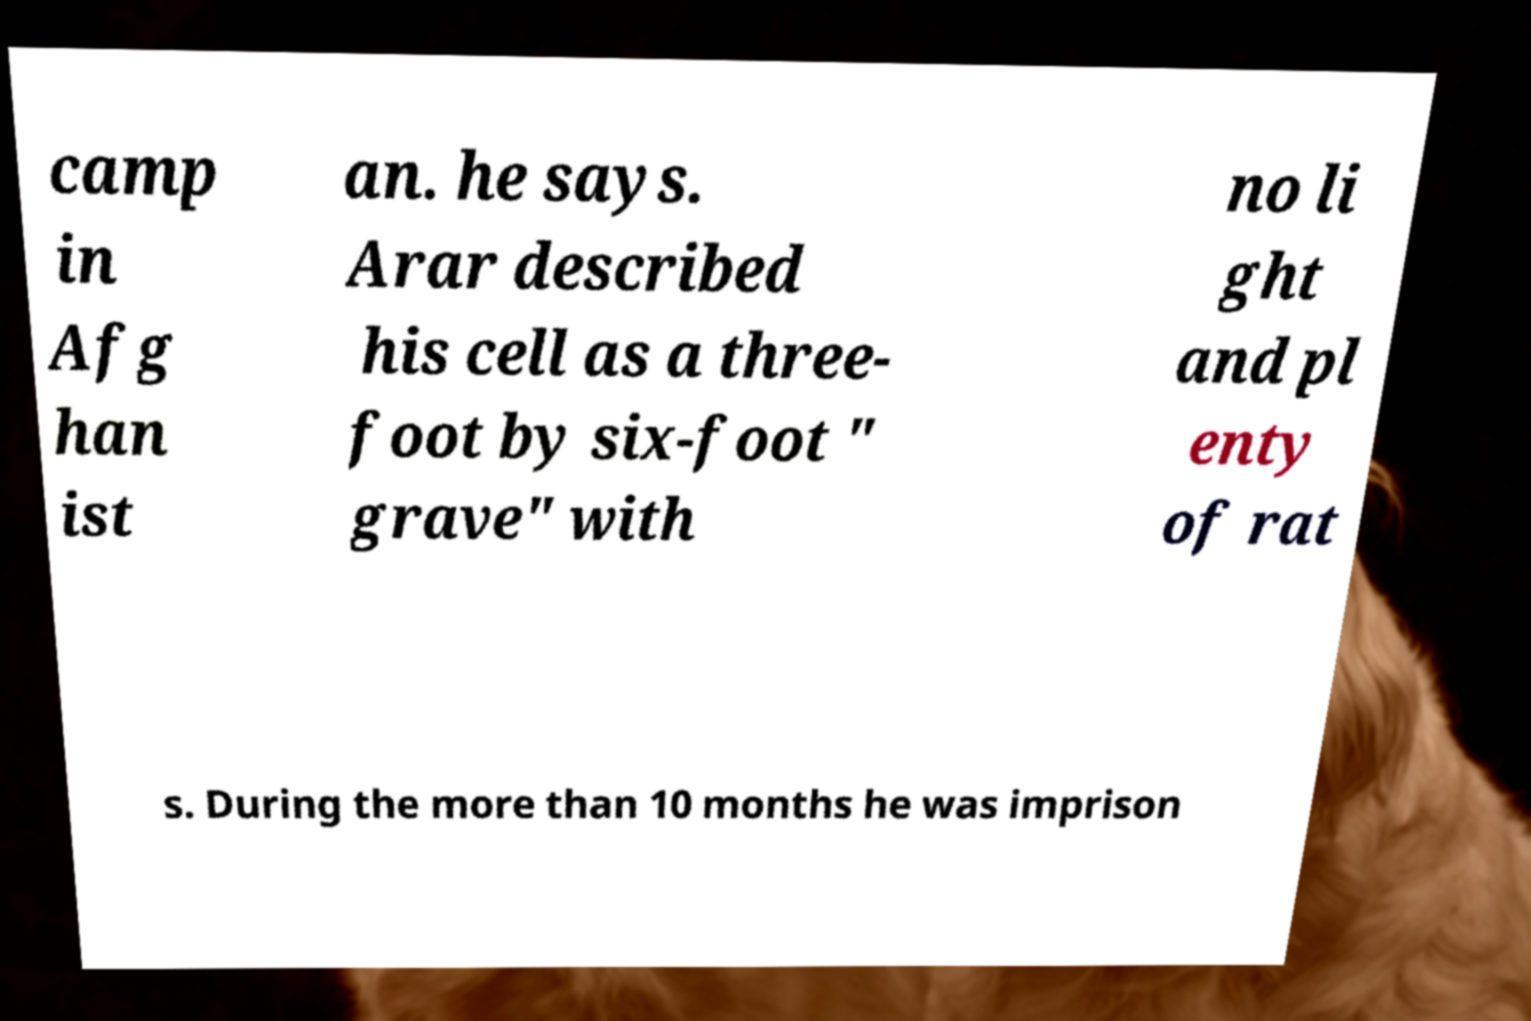Please read and relay the text visible in this image. What does it say? camp in Afg han ist an. he says. Arar described his cell as a three- foot by six-foot " grave" with no li ght and pl enty of rat s. During the more than 10 months he was imprison 